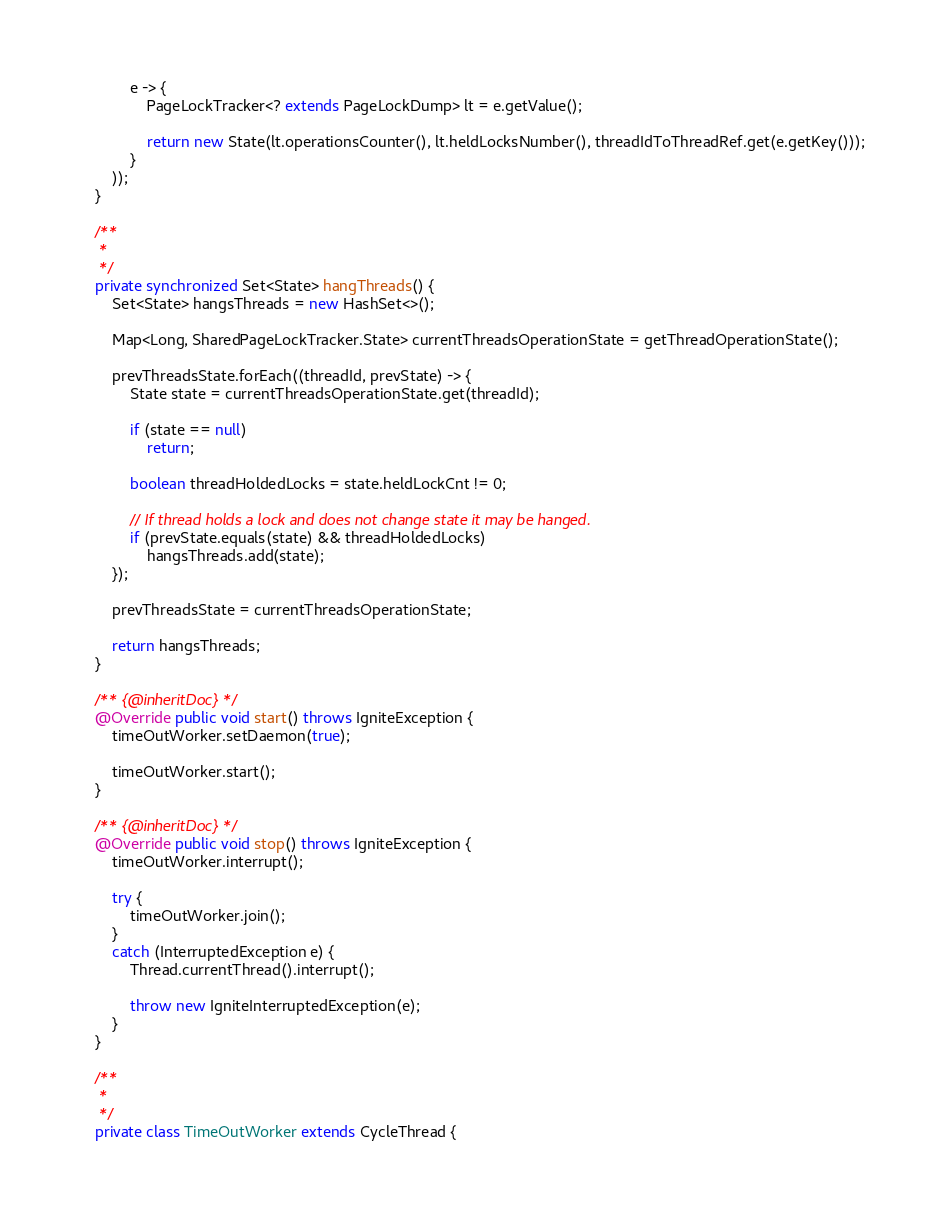<code> <loc_0><loc_0><loc_500><loc_500><_Java_>            e -> {
                PageLockTracker<? extends PageLockDump> lt = e.getValue();

                return new State(lt.operationsCounter(), lt.heldLocksNumber(), threadIdToThreadRef.get(e.getKey()));
            }
        ));
    }

    /**
     *
     */
    private synchronized Set<State> hangThreads() {
        Set<State> hangsThreads = new HashSet<>();

        Map<Long, SharedPageLockTracker.State> currentThreadsOperationState = getThreadOperationState();

        prevThreadsState.forEach((threadId, prevState) -> {
            State state = currentThreadsOperationState.get(threadId);

            if (state == null)
                return;

            boolean threadHoldedLocks = state.heldLockCnt != 0;

            // If thread holds a lock and does not change state it may be hanged.
            if (prevState.equals(state) && threadHoldedLocks)
                hangsThreads.add(state);
        });

        prevThreadsState = currentThreadsOperationState;

        return hangsThreads;
    }

    /** {@inheritDoc} */
    @Override public void start() throws IgniteException {
        timeOutWorker.setDaemon(true);

        timeOutWorker.start();
    }

    /** {@inheritDoc} */
    @Override public void stop() throws IgniteException {
        timeOutWorker.interrupt();

        try {
            timeOutWorker.join();
        }
        catch (InterruptedException e) {
            Thread.currentThread().interrupt();

            throw new IgniteInterruptedException(e);
        }
    }

    /**
     *
     */
    private class TimeOutWorker extends CycleThread {
</code> 